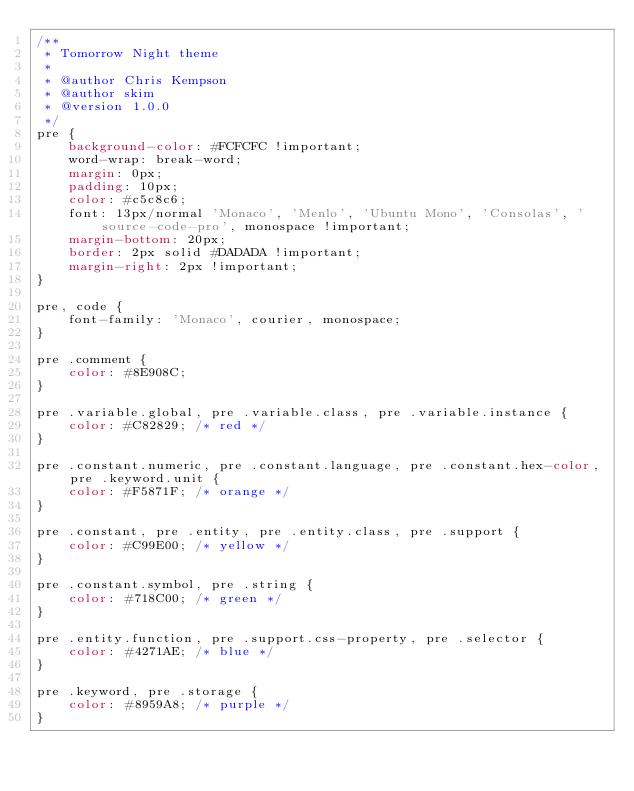Convert code to text. <code><loc_0><loc_0><loc_500><loc_500><_CSS_>/**
 * Tomorrow Night theme
 *
 * @author Chris Kempson
 * @author skim
 * @version 1.0.0
 */
pre {
    background-color: #FCFCFC !important;
    word-wrap: break-word;
    margin: 0px;
    padding: 10px;
    color: #c5c8c6;
    font: 13px/normal 'Monaco', 'Menlo', 'Ubuntu Mono', 'Consolas', 'source-code-pro', monospace !important;
    margin-bottom: 20px;
    border: 2px solid #DADADA !important;
    margin-right: 2px !important;
}

pre, code {
    font-family: 'Monaco', courier, monospace;
}

pre .comment {
    color: #8E908C;
}

pre .variable.global, pre .variable.class, pre .variable.instance {
    color: #C82829; /* red */
}

pre .constant.numeric, pre .constant.language, pre .constant.hex-color, pre .keyword.unit {
    color: #F5871F; /* orange */
}

pre .constant, pre .entity, pre .entity.class, pre .support {
    color: #C99E00; /* yellow */
}

pre .constant.symbol, pre .string {
    color: #718C00; /* green */
}

pre .entity.function, pre .support.css-property, pre .selector {
    color: #4271AE; /* blue */
}

pre .keyword, pre .storage {
    color: #8959A8; /* purple */
}</code> 